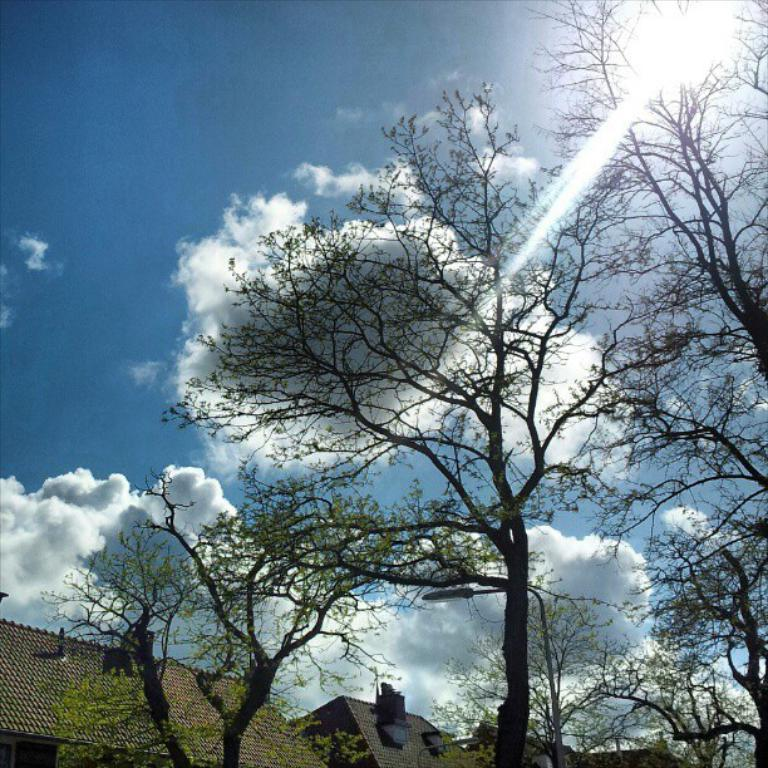What type of natural elements can be seen in the image? There are trees in the image. What type of man-made structures are visible in the image? There are houses in the image. What is visible in the background of the image? The sky is visible in the image. What can be observed in the sky? Clouds are present in the sky. What type of agreement is being signed by the trees in the image? There are no agreements or people present in the image, as it only features trees, houses, and the sky. 